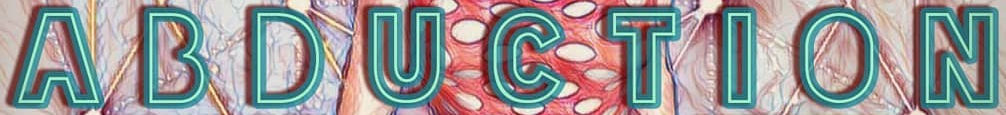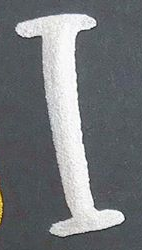Read the text content from these images in order, separated by a semicolon. ABDUCTION; I 